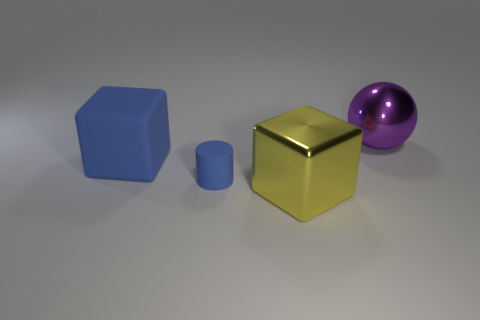What color is the large thing that is right of the yellow metal cube?
Provide a succinct answer. Purple. Are there the same number of purple metallic things right of the small cylinder and big cyan metallic cylinders?
Provide a succinct answer. No. How many other objects are the same shape as the large blue object?
Provide a short and direct response. 1. There is a purple metal object; how many blue matte blocks are left of it?
Offer a very short reply. 1. There is a thing that is both on the left side of the metallic cube and right of the large rubber block; what size is it?
Keep it short and to the point. Small. Is there a tiny gray sphere?
Make the answer very short. No. How many other things are the same size as the purple metal object?
Offer a very short reply. 2. Do the big thing that is in front of the large blue rubber object and the large object that is on the left side of the large yellow metallic object have the same color?
Your answer should be very brief. No. What size is the other rubber thing that is the same shape as the big yellow thing?
Offer a very short reply. Large. Is the material of the object that is on the right side of the yellow metal cube the same as the block that is behind the blue rubber cylinder?
Keep it short and to the point. No. 